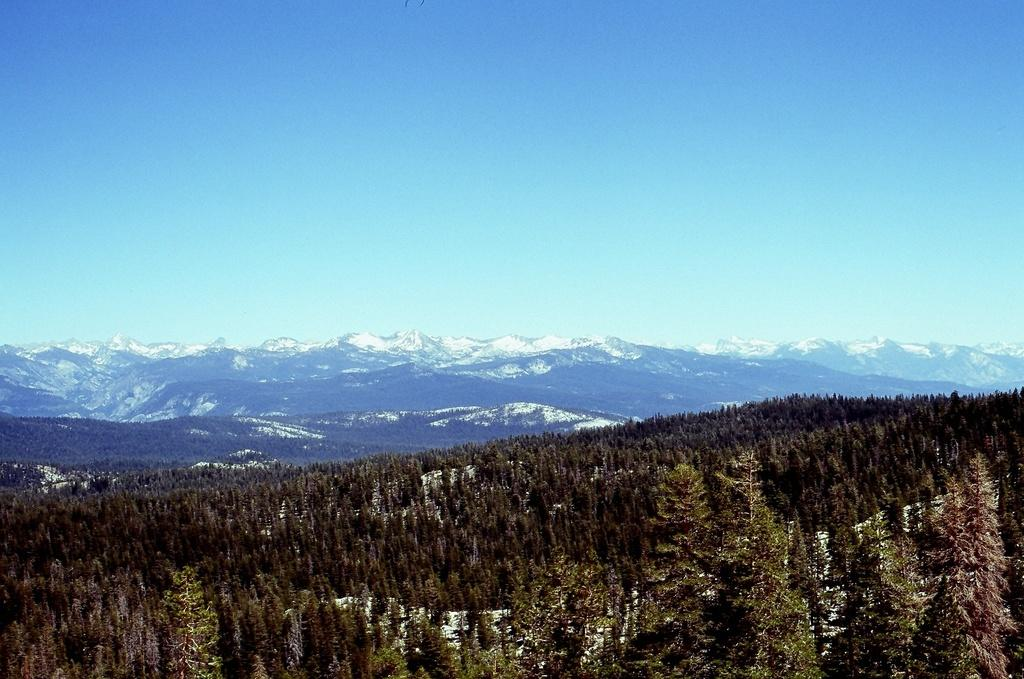What type of view is shown in the image? The image has an outside view. What can be seen in the foreground of the image? There are trees and mountains in the foreground of the image. What is visible in the background of the image? The sky is visible in the background of the image. Can you see any pipes in the image? There are no pipes present in the image. What type of head is visible on the trees in the image? Trees do not have heads, and there are no human or animal figures in the image. 